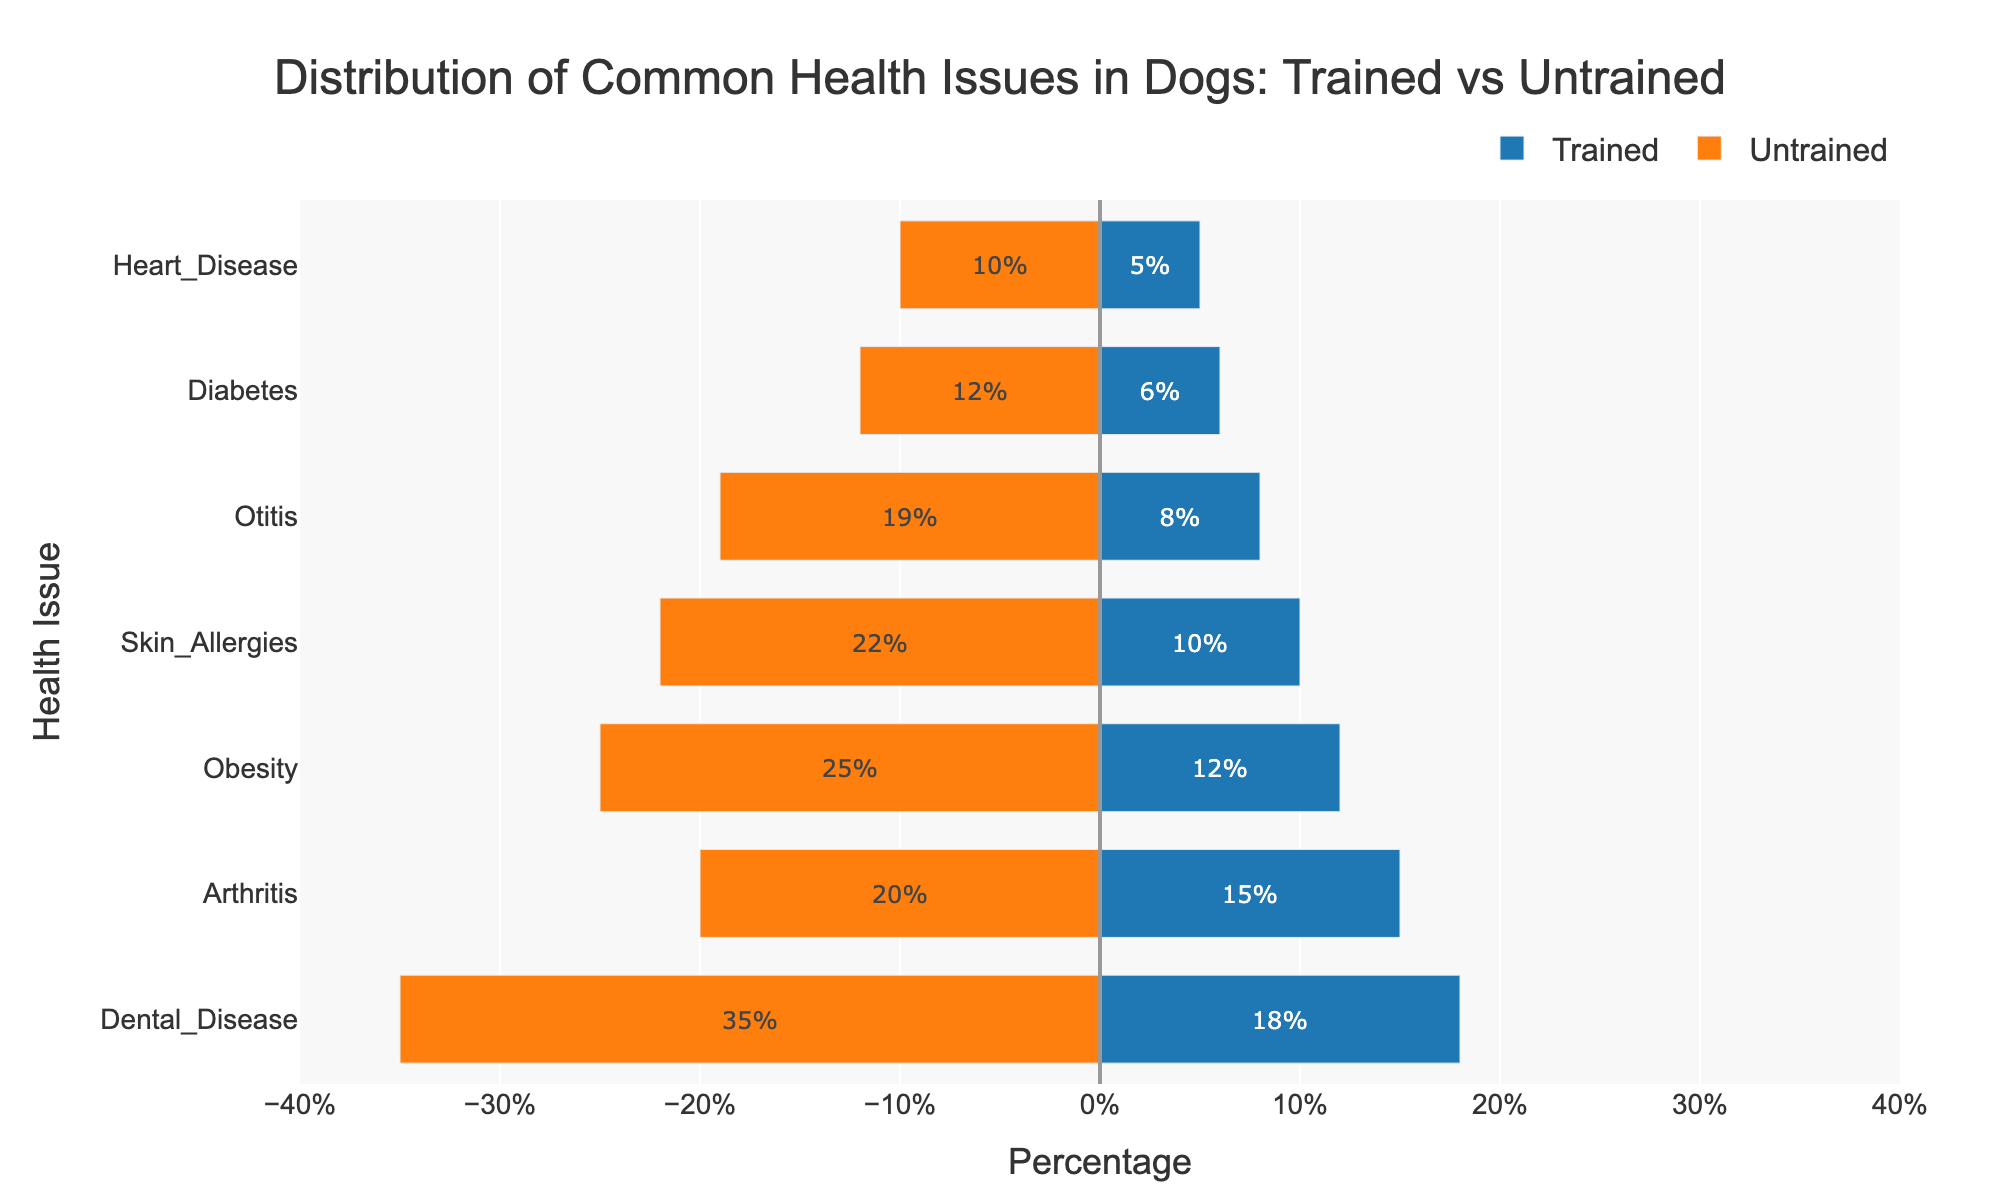Which health issue has the smallest percentage difference between trained and untrained dogs? The smallest percentage difference is evaluated by subtracting the "Trained" percentage from the "Untrained" percentage for each health issue. Diabetes has a 6% difference: 12% (Untrained) - 6% (Trained). The next closest is Heart Disease with a 5% gap: 10% (Untrained) - 5% (Trained).
Answer: Diabetes Which health issue shows the largest percentage decrease in trained dogs compared to untrained dogs? Find the difference between the "Untrained" and "Trained" percentages for each health issue. Dental Disease has the largest decrease: 35% (Untrained) versus 18% (Trained) results in a 17% decrease.
Answer: Dental Disease How much more common is Obesity in untrained dogs compared to trained dogs? Subtract the Obesity percentage for trained dogs from the untrained percentage: 25% (Untrained) - 12% (Trained) = 13%.
Answer: 13% Which health issue shows the smallest percentage in trained dogs? Look at the percentage values for trained dogs. Heart Disease has the smallest percentage, which is 5%.
Answer: Heart Disease How much more common is Otitis in untrained dogs than in trained dogs? Subtract the Otitis percentage for trained dogs from the untrained percentage: 19% (Untrained) - 8% (Trained) = 11%.
Answer: 11% What is the overall trend in health issues when comparing trained and untrained dogs? Observe the pattern in the plot. All the health issues have higher percentages in untrained dogs compared to trained dogs, indicating that common health issues are less prevalent in trained dogs.
Answer: Untrained dogs have more health issues Which health issue has almost double the percentage in untrained dogs compared to trained dogs? Compare the percentages: Skin Allergies (22% Untrained vs. 10% Trained) is a health issue where the percentage in untrained dogs is more than double that in trained dogs.
Answer: Skin Allergies What is the median percentage of health issues in trained dogs? Arrange percentages for trained dogs: 6%, 8%, 10%, 12%, 15%, 18%. The median is the average of the 3rd and 4th values: (10% + 12%)/2 = 11%.
Answer: 11% Which health issue is equally common in untrained dogs and almost equally uncommon in trained dogs, based on their visual bar lengths? Dental Disease appears to have a long bar for untrained dogs and a significantly shorter bar for trained dogs, indicating it is common among untrained dogs and less common in trained dogs.
Answer: Dental Disease In terms of visual lengths, which health issue has the second longest bar for untrained dogs? Visually assess the lengths of the bars for untrained dogs. Obesity appears to have the second longest bar after Dental Disease.
Answer: Obesity 